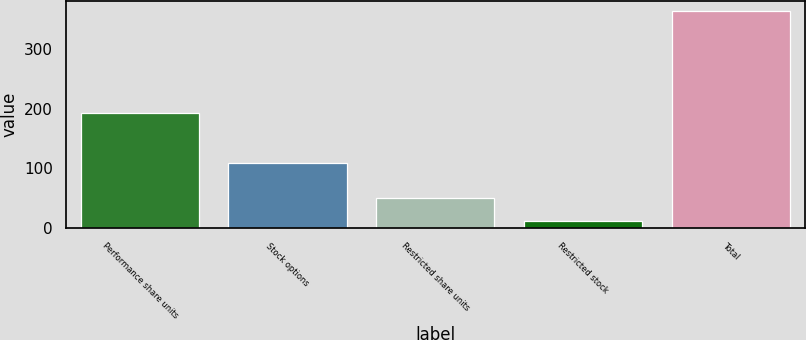Convert chart. <chart><loc_0><loc_0><loc_500><loc_500><bar_chart><fcel>Performance share units<fcel>Stock options<fcel>Restricted share units<fcel>Restricted stock<fcel>Total<nl><fcel>192<fcel>109<fcel>50<fcel>12<fcel>363<nl></chart> 